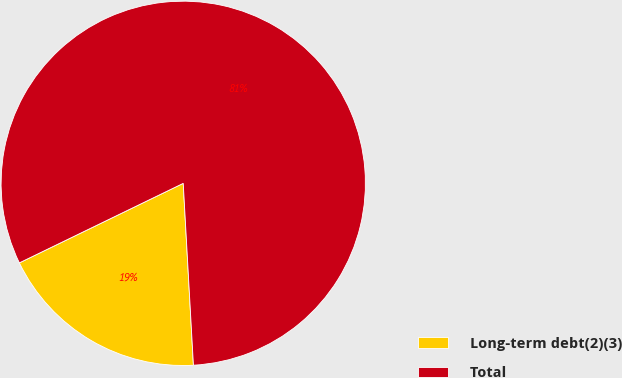<chart> <loc_0><loc_0><loc_500><loc_500><pie_chart><fcel>Long-term debt(2)(3)<fcel>Total<nl><fcel>18.7%<fcel>81.3%<nl></chart> 